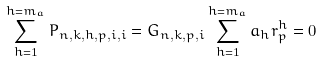Convert formula to latex. <formula><loc_0><loc_0><loc_500><loc_500>\sum _ { h = 1 } ^ { h = m _ { a } } P _ { n , k , h , p , i , i } = G _ { n , k , p , i } \sum _ { h = 1 } ^ { h = m _ { a } } a _ { h } r _ { p } ^ { h } = 0</formula> 